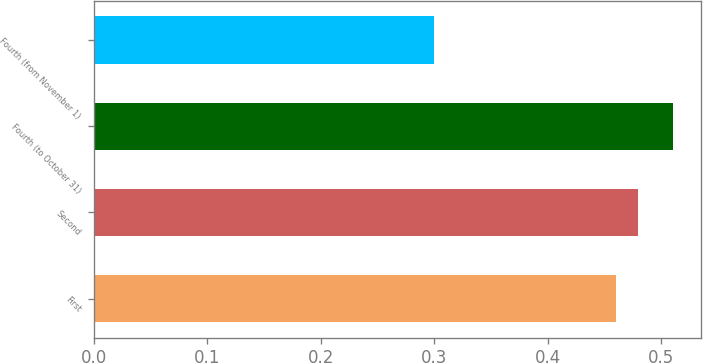Convert chart to OTSL. <chart><loc_0><loc_0><loc_500><loc_500><bar_chart><fcel>First<fcel>Second<fcel>Fourth (to October 31)<fcel>Fourth (from November 1)<nl><fcel>0.46<fcel>0.48<fcel>0.51<fcel>0.3<nl></chart> 